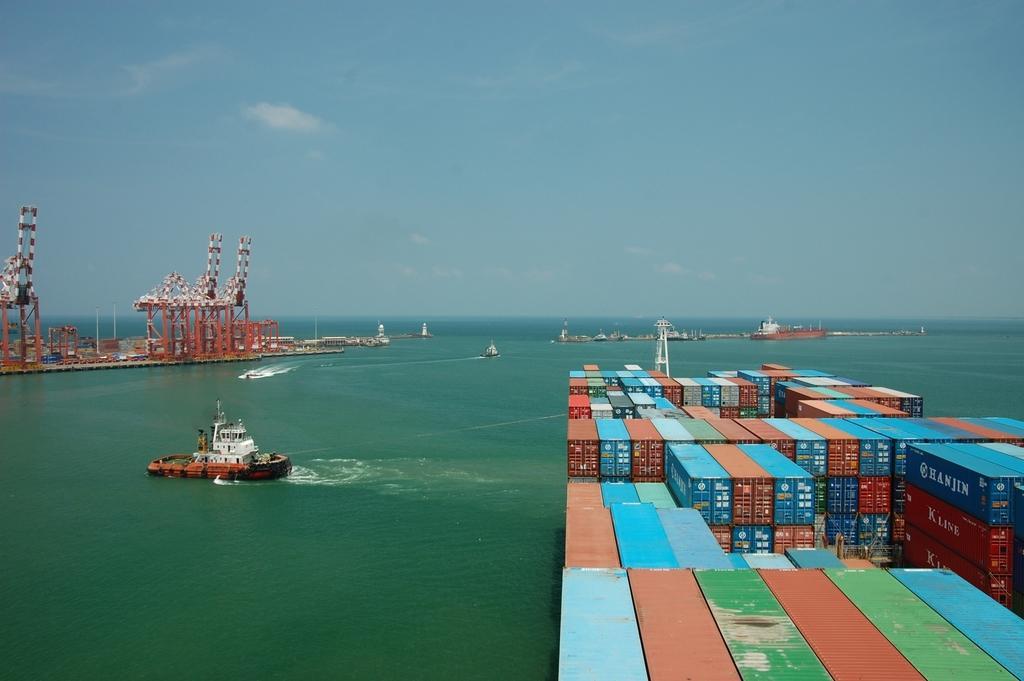Describe this image in one or two sentences. In this image we can see an ocean and right side of the image containers are present. The sky is in blue color. Left side of the image some area of metal things is there. 